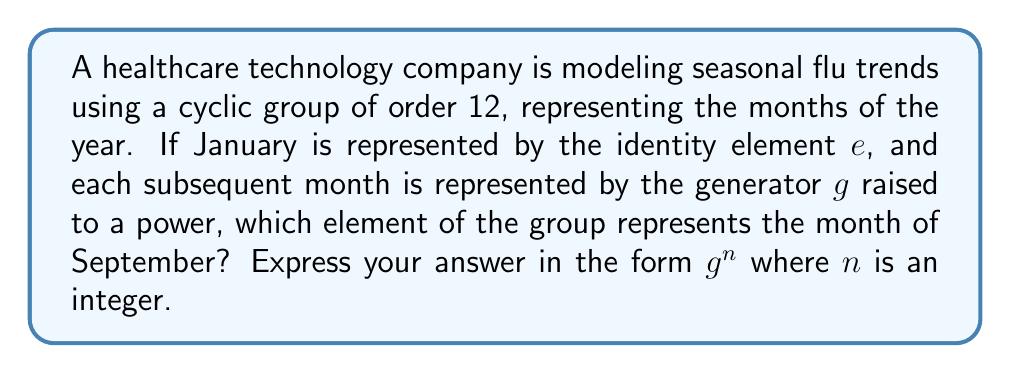Help me with this question. To solve this problem, we need to understand the structure of cyclic groups and how they can model periodic phenomena:

1) In a cyclic group of order 12, we have elements $\{e, g, g^2, ..., g^{11}\}$, where $g^{12} = e$.

2) Each element represents a month, with $e$ representing January:

   $e$ : January
   $g$ : February
   $g^2$ : March
   $g^3$ : April
   ...and so on.

3) To find which element represents September, we need to count how many steps September is from January.

4) Counting the months: 
   January (e) → February → March → April → May → June → July → August → September

5) We see that September is the 9th month when starting from January.

6) Therefore, September is represented by $g^8$ in our cyclic group.

This modeling allows for easy analysis of periodic health trends, as operations in the group correspond to movements through the annual cycle. For instance, multiplying by $g^3$ would represent moving forward by one quarter of a year.
Answer: $g^8$ 